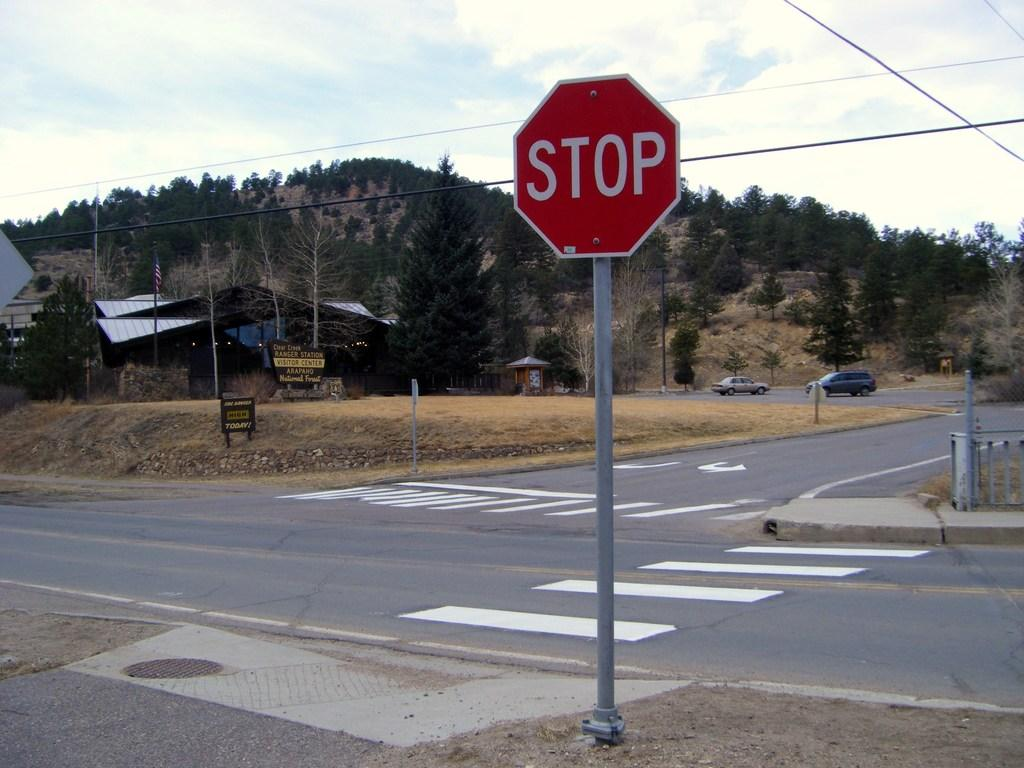Provide a one-sentence caption for the provided image. A stop sign might be in the wrong place at a 3 way intersection. 